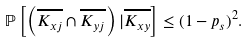Convert formula to latex. <formula><loc_0><loc_0><loc_500><loc_500>\mathbb { P } \left [ \left ( \overline { K _ { { x } j } } \cap \overline { K _ { { y } j } } \right ) | \overline { K _ { { x } { y } } } \right ] & \leq ( 1 - p _ { s } ) ^ { 2 } .</formula> 